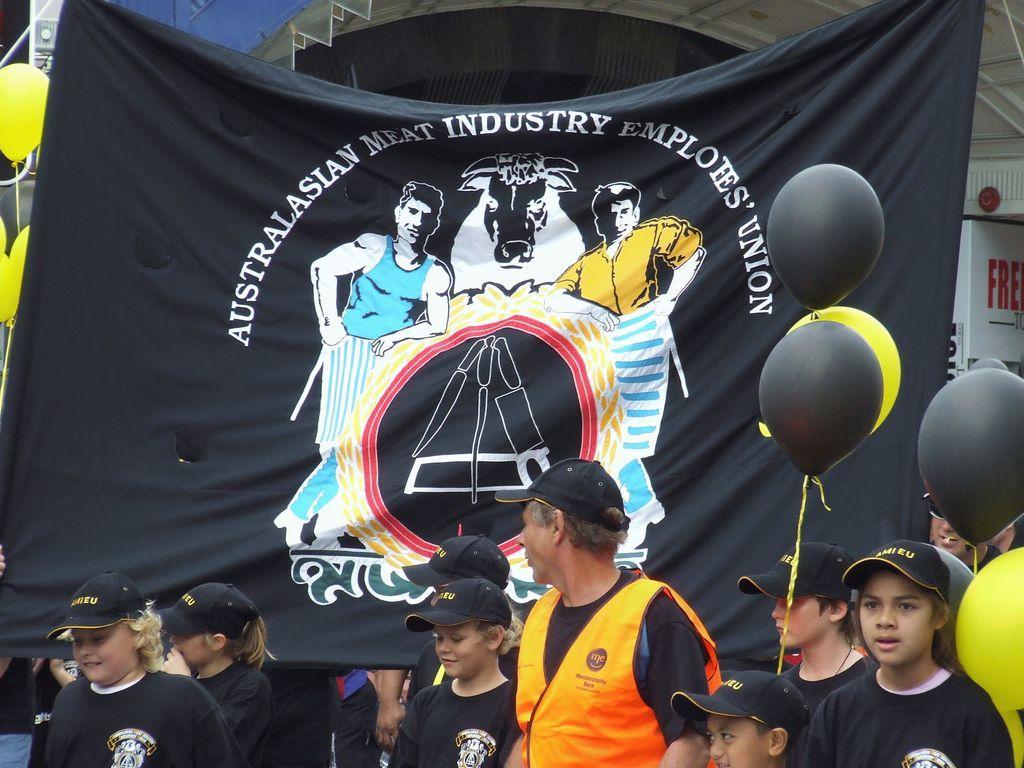Could you give a brief overview of what you see in this image? In the middle it is a banner in black color, there are pictures of two men and an animal. At the bottom two people are standing and they wore black color t-shirts, caps. In the middle a man is standing, he wore orange color coat. On the right side there are balloons. 